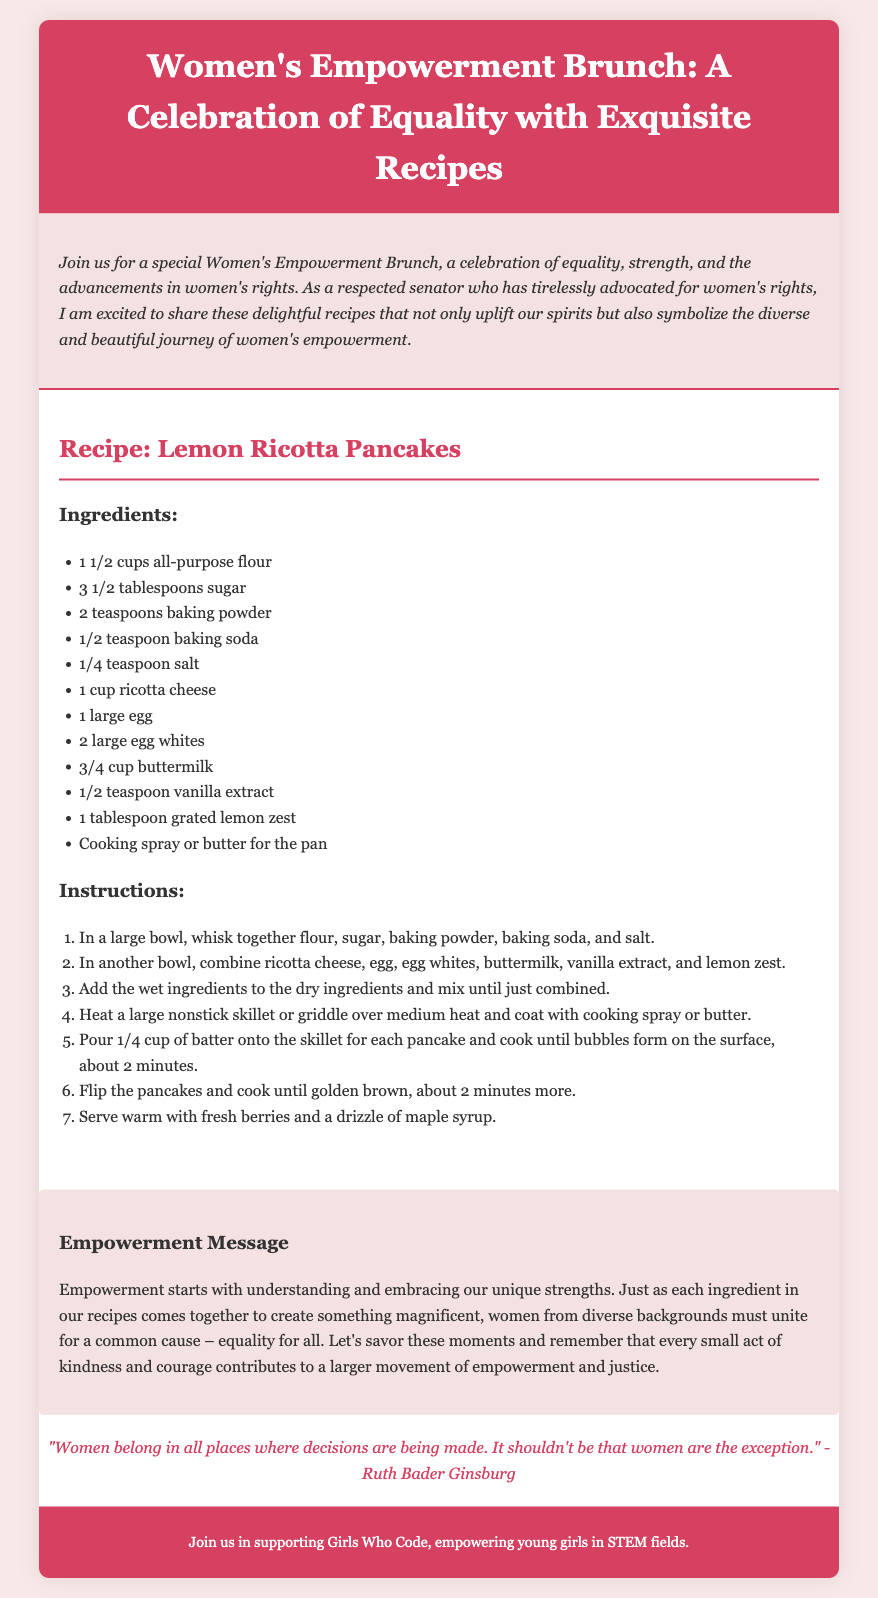What is the title of the event? The title of the event as stated in the document is "Women's Empowerment Brunch: A Celebration of Equality with Exquisite Recipes."
Answer: Women's Empowerment Brunch: A Celebration of Equality with Exquisite Recipes What is one of the main themes of the brunch? The document emphasizes the theme of equality, strength, and women's rights as a main theme of the brunch.
Answer: Equality How many large egg whites are needed for the recipe? The number of large egg whites specified in the recipe is two.
Answer: 2 What iconic quote is included in the document? The iconic quote included comes from Ruth Bader Ginsburg regarding women's representation in decision-making.
Answer: "Women belong in all places where decisions are being made. It shouldn't be that women are the exception." What ingredient provides the lemon flavor in the pancakes? The ingredient that provides the lemon flavor in the recipe is grated lemon zest.
Answer: Grated lemon zest What message is conveyed about empowerment? The document conveys that empowerment starts with embracing unique strengths and uniting for equality.
Answer: Understanding and embracing our unique strengths What is the purpose of the brunch according to the introduction? The purpose of the brunch is to celebrate advancements in women’s rights and provide delightful recipes.
Answer: Celebrate advancements in women’s rights Which organization is mentioned as supportive of the brunch? The organization mentioned in the footer as supportive is Girls Who Code.
Answer: Girls Who Code 